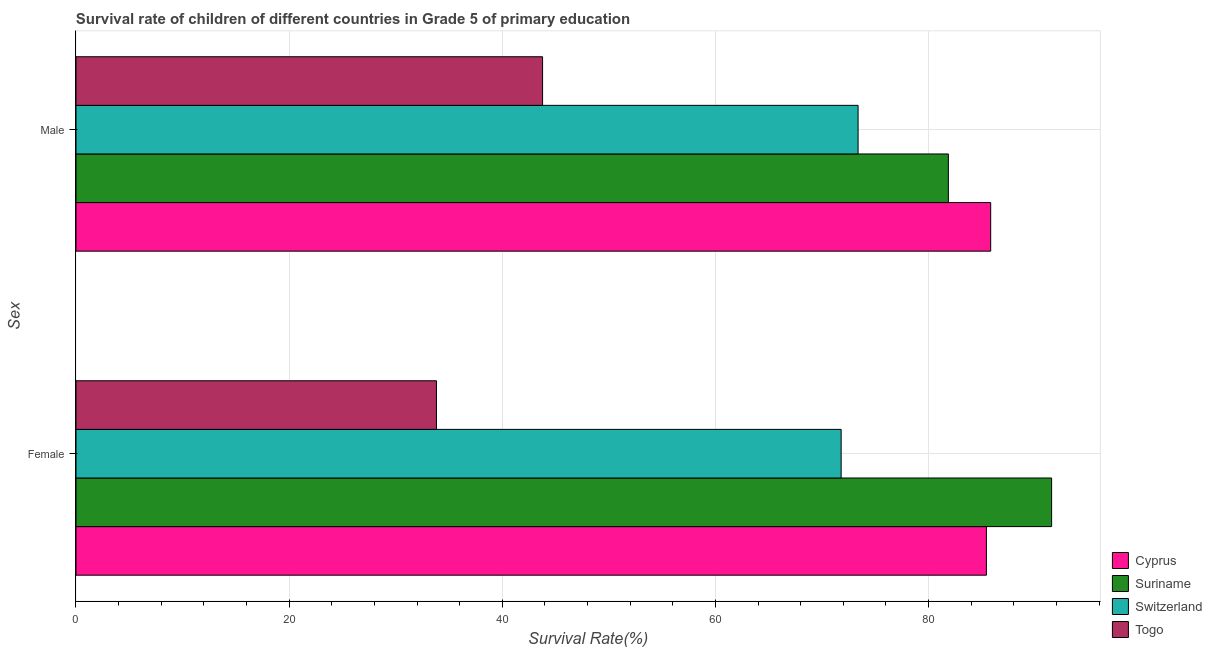Are the number of bars per tick equal to the number of legend labels?
Make the answer very short. Yes. How many bars are there on the 1st tick from the top?
Ensure brevity in your answer.  4. How many bars are there on the 2nd tick from the bottom?
Ensure brevity in your answer.  4. What is the label of the 2nd group of bars from the top?
Give a very brief answer. Female. What is the survival rate of female students in primary education in Togo?
Offer a terse response. 33.82. Across all countries, what is the maximum survival rate of female students in primary education?
Give a very brief answer. 91.54. Across all countries, what is the minimum survival rate of female students in primary education?
Give a very brief answer. 33.82. In which country was the survival rate of male students in primary education maximum?
Keep it short and to the point. Cyprus. In which country was the survival rate of male students in primary education minimum?
Offer a very short reply. Togo. What is the total survival rate of male students in primary education in the graph?
Ensure brevity in your answer.  284.85. What is the difference between the survival rate of male students in primary education in Cyprus and that in Suriname?
Your answer should be very brief. 3.97. What is the difference between the survival rate of female students in primary education in Cyprus and the survival rate of male students in primary education in Switzerland?
Provide a succinct answer. 12.04. What is the average survival rate of male students in primary education per country?
Keep it short and to the point. 71.21. What is the difference between the survival rate of male students in primary education and survival rate of female students in primary education in Cyprus?
Give a very brief answer. 0.4. What is the ratio of the survival rate of male students in primary education in Switzerland to that in Togo?
Ensure brevity in your answer.  1.68. What does the 3rd bar from the top in Male represents?
Your answer should be compact. Suriname. What does the 1st bar from the bottom in Male represents?
Your answer should be compact. Cyprus. How many bars are there?
Keep it short and to the point. 8. What is the difference between two consecutive major ticks on the X-axis?
Make the answer very short. 20. Does the graph contain any zero values?
Provide a short and direct response. No. How many legend labels are there?
Your answer should be very brief. 4. What is the title of the graph?
Your response must be concise. Survival rate of children of different countries in Grade 5 of primary education. What is the label or title of the X-axis?
Make the answer very short. Survival Rate(%). What is the label or title of the Y-axis?
Ensure brevity in your answer.  Sex. What is the Survival Rate(%) in Cyprus in Female?
Your answer should be compact. 85.43. What is the Survival Rate(%) in Suriname in Female?
Your answer should be compact. 91.54. What is the Survival Rate(%) in Switzerland in Female?
Give a very brief answer. 71.8. What is the Survival Rate(%) in Togo in Female?
Provide a short and direct response. 33.82. What is the Survival Rate(%) of Cyprus in Male?
Make the answer very short. 85.83. What is the Survival Rate(%) of Suriname in Male?
Your answer should be compact. 81.86. What is the Survival Rate(%) of Switzerland in Male?
Provide a short and direct response. 73.39. What is the Survival Rate(%) of Togo in Male?
Provide a succinct answer. 43.78. Across all Sex, what is the maximum Survival Rate(%) of Cyprus?
Provide a succinct answer. 85.83. Across all Sex, what is the maximum Survival Rate(%) in Suriname?
Your answer should be compact. 91.54. Across all Sex, what is the maximum Survival Rate(%) in Switzerland?
Offer a very short reply. 73.39. Across all Sex, what is the maximum Survival Rate(%) in Togo?
Ensure brevity in your answer.  43.78. Across all Sex, what is the minimum Survival Rate(%) of Cyprus?
Make the answer very short. 85.43. Across all Sex, what is the minimum Survival Rate(%) of Suriname?
Ensure brevity in your answer.  81.86. Across all Sex, what is the minimum Survival Rate(%) in Switzerland?
Offer a terse response. 71.8. Across all Sex, what is the minimum Survival Rate(%) in Togo?
Provide a short and direct response. 33.82. What is the total Survival Rate(%) of Cyprus in the graph?
Your answer should be very brief. 171.25. What is the total Survival Rate(%) of Suriname in the graph?
Your answer should be compact. 173.4. What is the total Survival Rate(%) of Switzerland in the graph?
Provide a short and direct response. 145.18. What is the total Survival Rate(%) in Togo in the graph?
Provide a succinct answer. 77.6. What is the difference between the Survival Rate(%) of Cyprus in Female and that in Male?
Ensure brevity in your answer.  -0.4. What is the difference between the Survival Rate(%) in Suriname in Female and that in Male?
Your answer should be very brief. 9.69. What is the difference between the Survival Rate(%) of Switzerland in Female and that in Male?
Give a very brief answer. -1.59. What is the difference between the Survival Rate(%) in Togo in Female and that in Male?
Offer a terse response. -9.96. What is the difference between the Survival Rate(%) in Cyprus in Female and the Survival Rate(%) in Suriname in Male?
Provide a succinct answer. 3.57. What is the difference between the Survival Rate(%) of Cyprus in Female and the Survival Rate(%) of Switzerland in Male?
Your response must be concise. 12.04. What is the difference between the Survival Rate(%) in Cyprus in Female and the Survival Rate(%) in Togo in Male?
Your answer should be compact. 41.65. What is the difference between the Survival Rate(%) of Suriname in Female and the Survival Rate(%) of Switzerland in Male?
Offer a terse response. 18.16. What is the difference between the Survival Rate(%) in Suriname in Female and the Survival Rate(%) in Togo in Male?
Ensure brevity in your answer.  47.76. What is the difference between the Survival Rate(%) of Switzerland in Female and the Survival Rate(%) of Togo in Male?
Provide a short and direct response. 28.02. What is the average Survival Rate(%) in Cyprus per Sex?
Give a very brief answer. 85.63. What is the average Survival Rate(%) in Suriname per Sex?
Make the answer very short. 86.7. What is the average Survival Rate(%) of Switzerland per Sex?
Provide a succinct answer. 72.59. What is the average Survival Rate(%) of Togo per Sex?
Your response must be concise. 38.8. What is the difference between the Survival Rate(%) of Cyprus and Survival Rate(%) of Suriname in Female?
Keep it short and to the point. -6.12. What is the difference between the Survival Rate(%) in Cyprus and Survival Rate(%) in Switzerland in Female?
Provide a short and direct response. 13.63. What is the difference between the Survival Rate(%) of Cyprus and Survival Rate(%) of Togo in Female?
Offer a very short reply. 51.6. What is the difference between the Survival Rate(%) of Suriname and Survival Rate(%) of Switzerland in Female?
Keep it short and to the point. 19.75. What is the difference between the Survival Rate(%) in Suriname and Survival Rate(%) in Togo in Female?
Make the answer very short. 57.72. What is the difference between the Survival Rate(%) of Switzerland and Survival Rate(%) of Togo in Female?
Your answer should be very brief. 37.97. What is the difference between the Survival Rate(%) of Cyprus and Survival Rate(%) of Suriname in Male?
Offer a very short reply. 3.97. What is the difference between the Survival Rate(%) of Cyprus and Survival Rate(%) of Switzerland in Male?
Provide a short and direct response. 12.44. What is the difference between the Survival Rate(%) in Cyprus and Survival Rate(%) in Togo in Male?
Give a very brief answer. 42.05. What is the difference between the Survival Rate(%) in Suriname and Survival Rate(%) in Switzerland in Male?
Give a very brief answer. 8.47. What is the difference between the Survival Rate(%) of Suriname and Survival Rate(%) of Togo in Male?
Provide a short and direct response. 38.08. What is the difference between the Survival Rate(%) in Switzerland and Survival Rate(%) in Togo in Male?
Keep it short and to the point. 29.61. What is the ratio of the Survival Rate(%) in Cyprus in Female to that in Male?
Your answer should be compact. 1. What is the ratio of the Survival Rate(%) of Suriname in Female to that in Male?
Offer a terse response. 1.12. What is the ratio of the Survival Rate(%) of Switzerland in Female to that in Male?
Offer a terse response. 0.98. What is the ratio of the Survival Rate(%) of Togo in Female to that in Male?
Provide a succinct answer. 0.77. What is the difference between the highest and the second highest Survival Rate(%) of Cyprus?
Ensure brevity in your answer.  0.4. What is the difference between the highest and the second highest Survival Rate(%) in Suriname?
Offer a very short reply. 9.69. What is the difference between the highest and the second highest Survival Rate(%) of Switzerland?
Make the answer very short. 1.59. What is the difference between the highest and the second highest Survival Rate(%) of Togo?
Ensure brevity in your answer.  9.96. What is the difference between the highest and the lowest Survival Rate(%) in Cyprus?
Provide a succinct answer. 0.4. What is the difference between the highest and the lowest Survival Rate(%) of Suriname?
Offer a very short reply. 9.69. What is the difference between the highest and the lowest Survival Rate(%) of Switzerland?
Your answer should be very brief. 1.59. What is the difference between the highest and the lowest Survival Rate(%) in Togo?
Give a very brief answer. 9.96. 